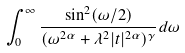Convert formula to latex. <formula><loc_0><loc_0><loc_500><loc_500>\int _ { 0 } ^ { \infty } \frac { \sin ^ { 2 } ( \omega / 2 ) } { ( \omega ^ { 2 \alpha } + \lambda ^ { 2 } | t | ^ { 2 \alpha } ) ^ { \gamma } } d \omega</formula> 